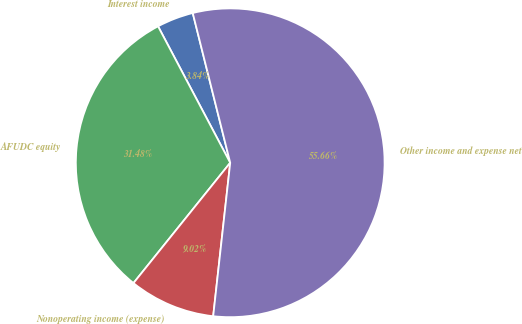Convert chart. <chart><loc_0><loc_0><loc_500><loc_500><pie_chart><fcel>Interest income<fcel>AFUDC equity<fcel>Nonoperating income (expense)<fcel>Other income and expense net<nl><fcel>3.84%<fcel>31.48%<fcel>9.02%<fcel>55.66%<nl></chart> 